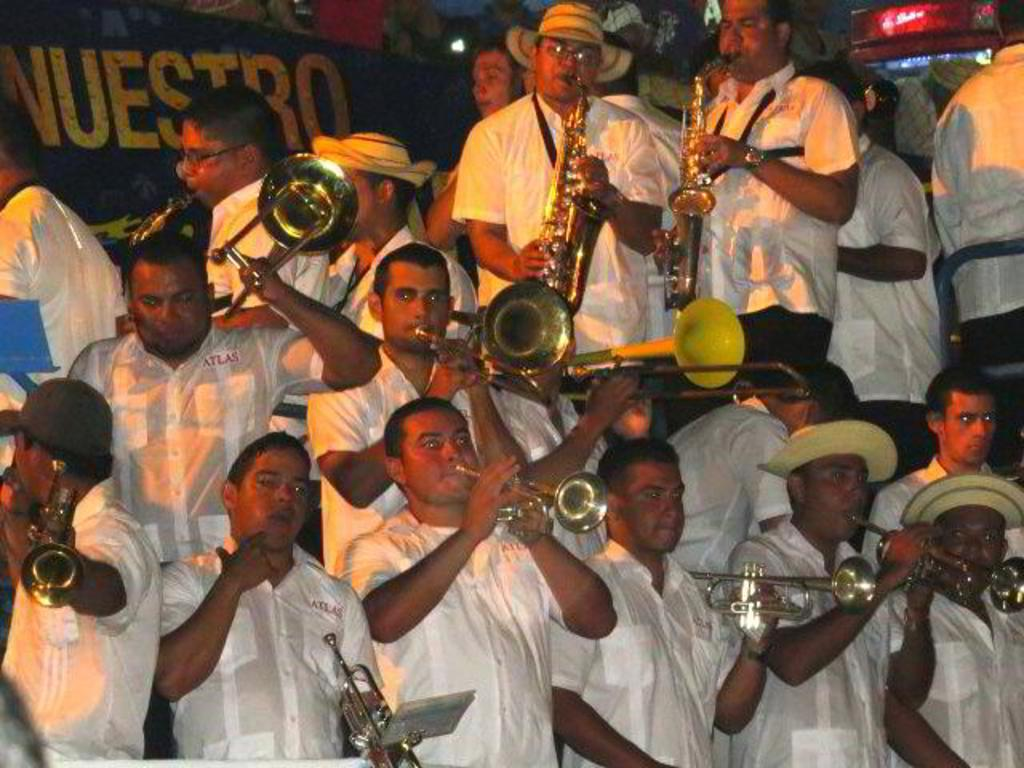What are the people in the image doing? The people in the image are playing musical instruments. What are the people wearing on their upper bodies? The people are wearing white shirts. What type of headwear can be seen on the people in the image? The people are wearing hats. Can you see a bridge in the background of the image? There is no bridge visible in the image. What type of pan is being used by the people in the image? The people in the image are not using a pan; they are playing musical instruments. 